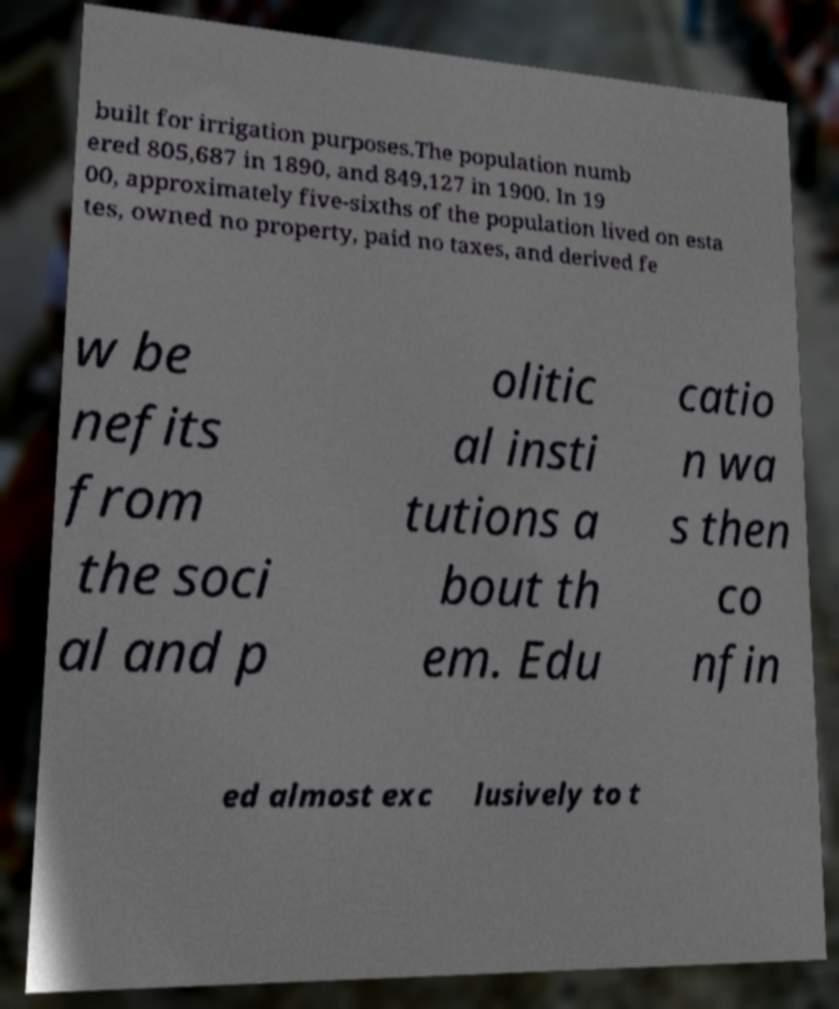What messages or text are displayed in this image? I need them in a readable, typed format. built for irrigation purposes.The population numb ered 805,687 in 1890, and 849,127 in 1900. In 19 00, approximately five-sixths of the population lived on esta tes, owned no property, paid no taxes, and derived fe w be nefits from the soci al and p olitic al insti tutions a bout th em. Edu catio n wa s then co nfin ed almost exc lusively to t 